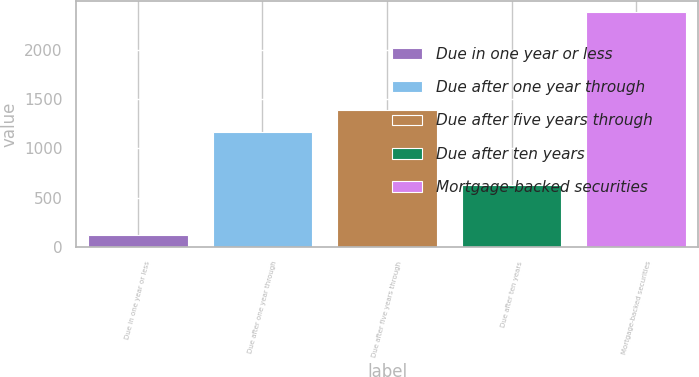Convert chart to OTSL. <chart><loc_0><loc_0><loc_500><loc_500><bar_chart><fcel>Due in one year or less<fcel>Due after one year through<fcel>Due after five years through<fcel>Due after ten years<fcel>Mortgage-backed securities<nl><fcel>128<fcel>1168.3<fcel>1393<fcel>630.7<fcel>2375<nl></chart> 